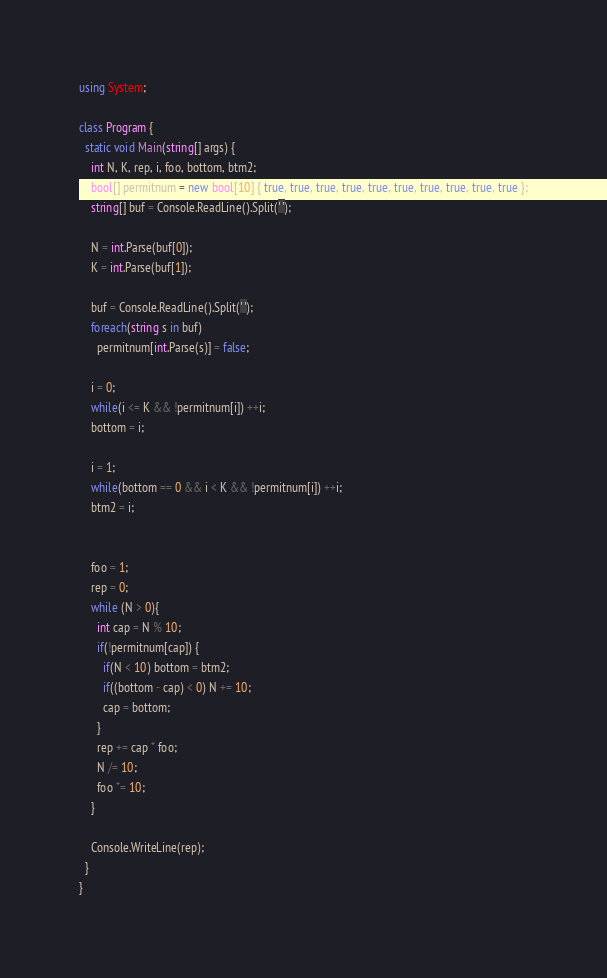<code> <loc_0><loc_0><loc_500><loc_500><_C#_>using System;

class Program {
  static void Main(string[] args) {
    int N, K, rep, i, foo, bottom, btm2;
    bool[] permitnum = new bool[10] { true, true, true, true, true, true, true, true, true, true };
    string[] buf = Console.ReadLine().Split(' ');

    N = int.Parse(buf[0]);
    K = int.Parse(buf[1]);

    buf = Console.ReadLine().Split(' ');
    foreach(string s in buf) 
      permitnum[int.Parse(s)] = false;
    
    i = 0;
    while(i <= K && !permitnum[i]) ++i;
    bottom = i;

    i = 1;
    while(bottom == 0 && i < K && !permitnum[i]) ++i;
    btm2 = i;


    foo = 1;
    rep = 0;
    while (N > 0){
      int cap = N % 10;
      if(!permitnum[cap]) {
        if(N < 10) bottom = btm2;
        if((bottom - cap) < 0) N += 10;
        cap = bottom;
      }
      rep += cap * foo;
      N /= 10;
      foo *= 10;
    }

    Console.WriteLine(rep);
  }
}
</code> 